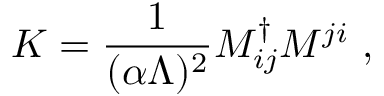Convert formula to latex. <formula><loc_0><loc_0><loc_500><loc_500>K = { \frac { 1 } { ( \alpha \Lambda ) ^ { 2 } } } M _ { i j } ^ { \dag } M ^ { j i } \ ,</formula> 